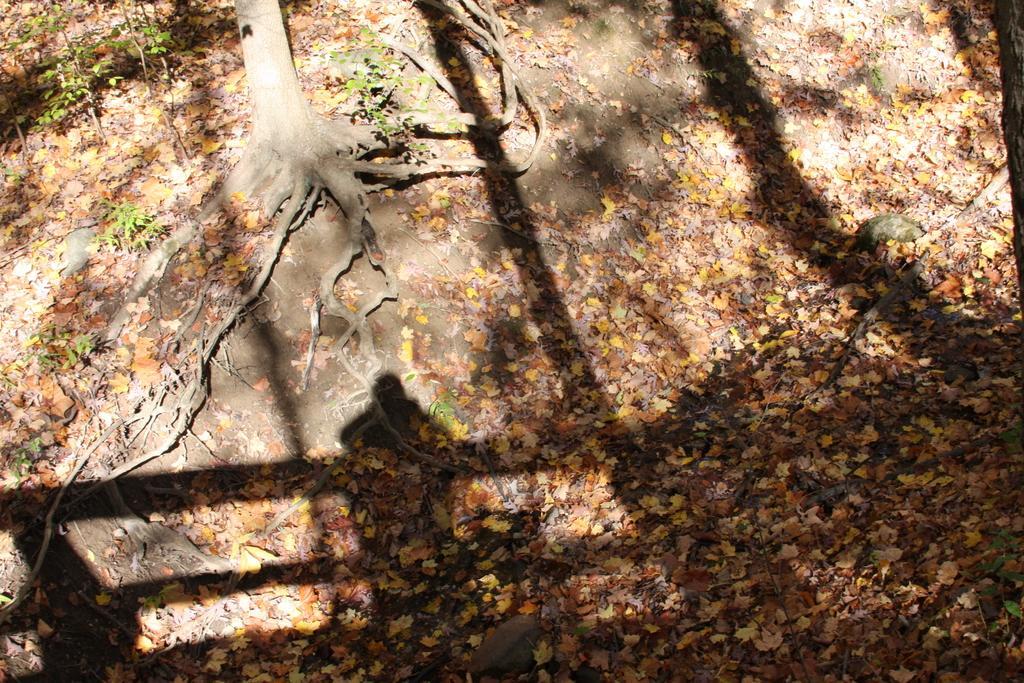Could you give a brief overview of what you see in this image? This picture shows a tree bark with roots and we see leaves on the ground. 